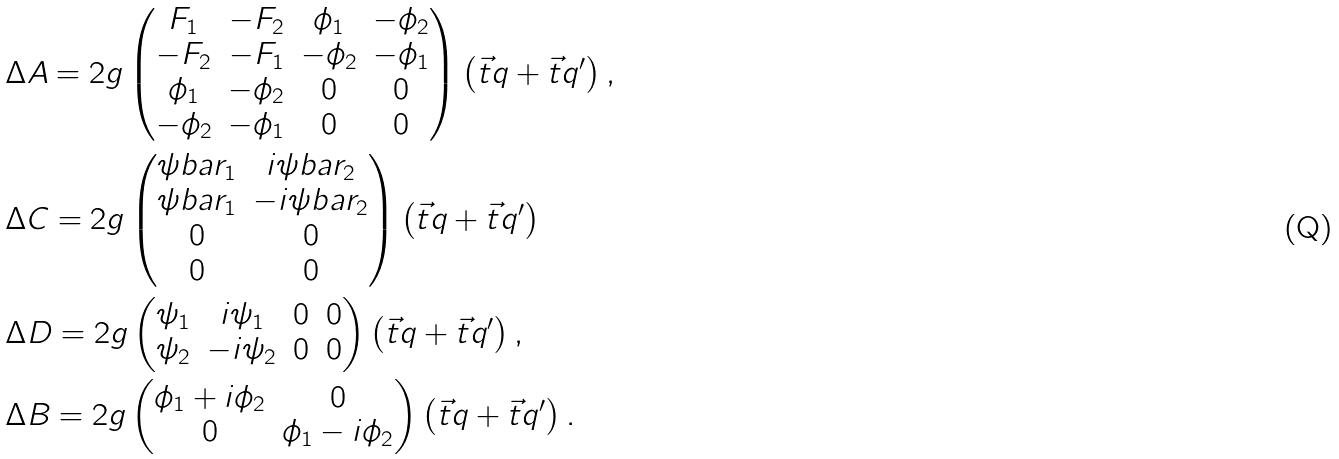<formula> <loc_0><loc_0><loc_500><loc_500>& \Delta A = 2 g \begin{pmatrix} F _ { 1 } & - F _ { 2 } & \phi _ { 1 } & - \phi _ { 2 } \\ - F _ { 2 } & - F _ { 1 } & - \phi _ { 2 } & - \phi _ { 1 } \\ \phi _ { 1 } & - \phi _ { 2 } & 0 & 0 \\ - \phi _ { 2 } & - \phi _ { 1 } & 0 & 0 \\ \end{pmatrix} \left ( \vec { t } { q } + \vec { t } { q ^ { \prime } } \right ) , \\ & \Delta C = 2 g \begin{pmatrix} \psi b a r _ { 1 } & i \psi b a r _ { 2 } \\ \psi b a r _ { 1 } & - i \psi b a r _ { 2 } \\ 0 & 0 \\ 0 & 0 \end{pmatrix} \left ( \vec { t } { q } + \vec { t } { q ^ { \prime } } \right ) \\ & \Delta D = 2 g \begin{pmatrix} \psi _ { 1 } & i \psi _ { 1 } & 0 & 0 \\ \psi _ { 2 } & - i \psi _ { 2 } & 0 & 0 \end{pmatrix} \left ( \vec { t } { q } + \vec { t } { q ^ { \prime } } \right ) , \\ & \Delta B = 2 g \begin{pmatrix} \phi _ { 1 } + i \phi _ { 2 } & 0 \\ 0 & \phi _ { 1 } - i \phi _ { 2 } \end{pmatrix} \left ( \vec { t } { q } + \vec { t } { q ^ { \prime } } \right ) .</formula> 